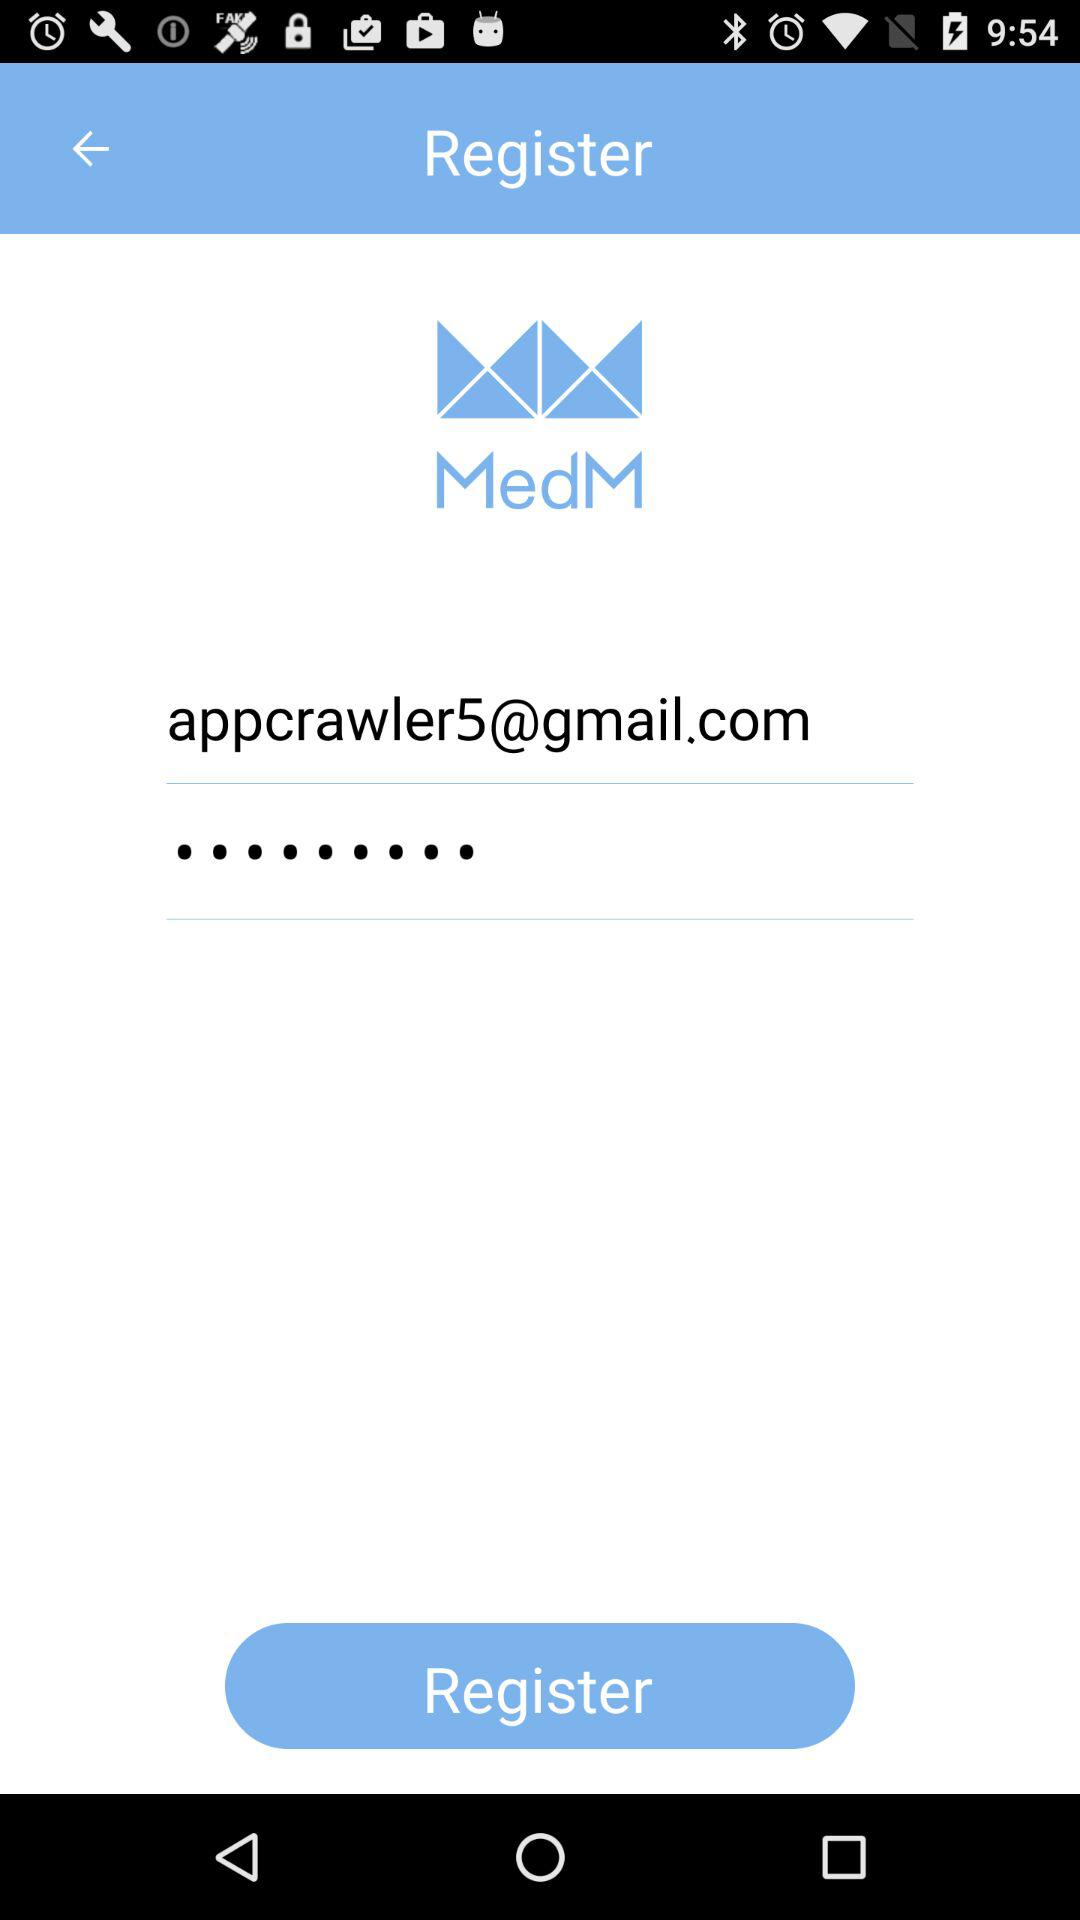What is the name of the application? The name of the application is "MedM". 